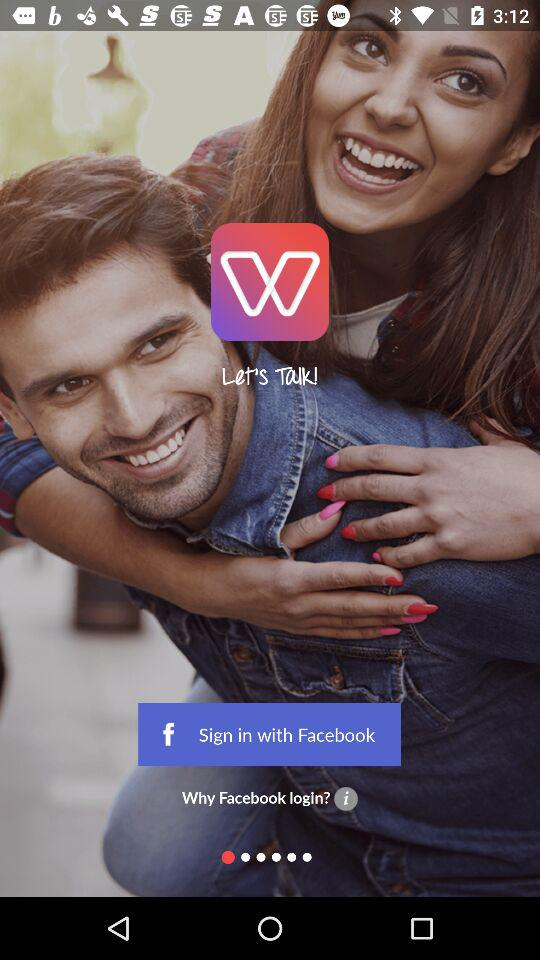What application can be used for sign-in? The application that can be used for sign-in is "Facebook". 